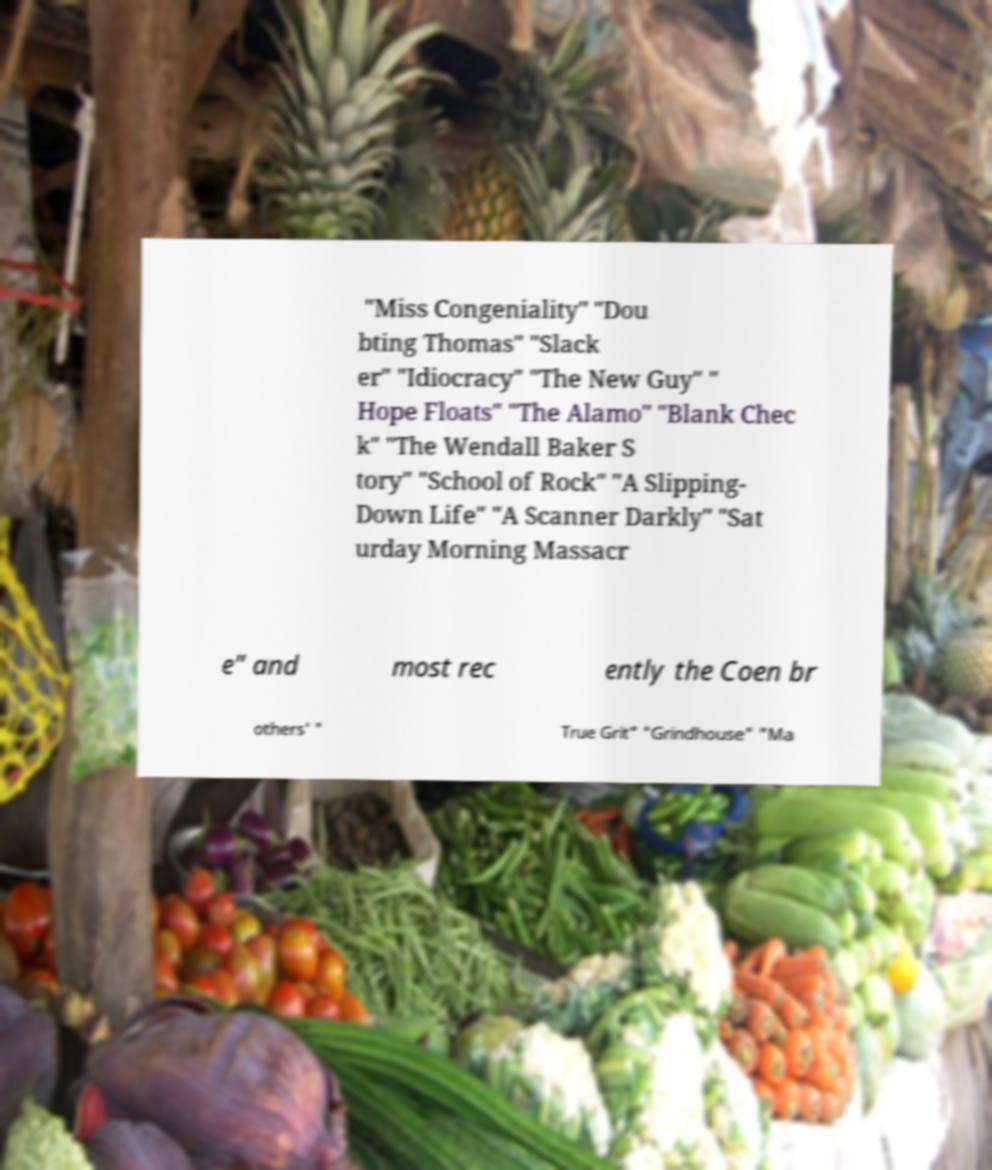Could you extract and type out the text from this image? "Miss Congeniality" "Dou bting Thomas" "Slack er" "Idiocracy" "The New Guy" " Hope Floats" "The Alamo" "Blank Chec k" "The Wendall Baker S tory" "School of Rock" "A Slipping- Down Life" "A Scanner Darkly" "Sat urday Morning Massacr e" and most rec ently the Coen br others' " True Grit" "Grindhouse" "Ma 